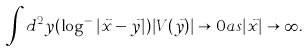<formula> <loc_0><loc_0><loc_500><loc_500>\int d ^ { 2 } y ( \log ^ { - } | \vec { x } - \vec { y } | ) | V ( \vec { y } ) | \rightarrow 0 a s | \vec { x } | \rightarrow \infty .</formula> 